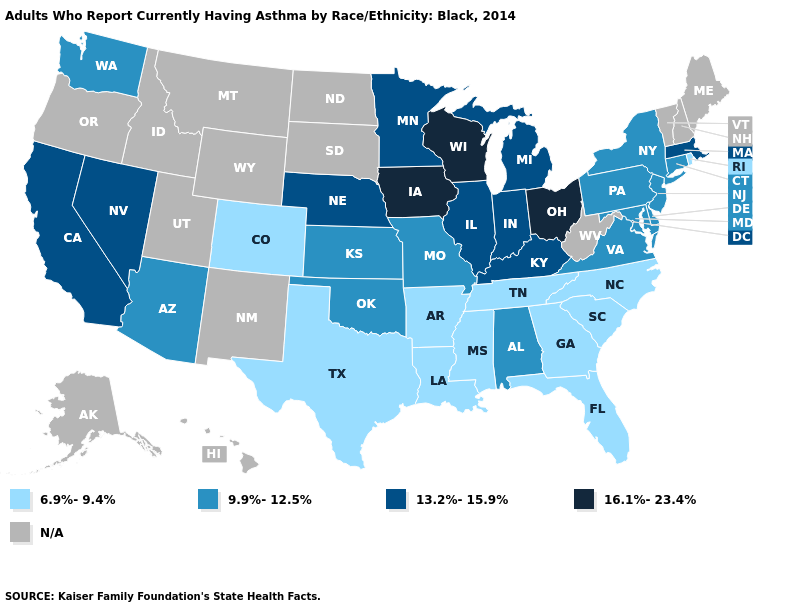Does the first symbol in the legend represent the smallest category?
Quick response, please. Yes. Name the states that have a value in the range 13.2%-15.9%?
Write a very short answer. California, Illinois, Indiana, Kentucky, Massachusetts, Michigan, Minnesota, Nebraska, Nevada. What is the value of Illinois?
Give a very brief answer. 13.2%-15.9%. How many symbols are there in the legend?
Concise answer only. 5. Name the states that have a value in the range N/A?
Short answer required. Alaska, Hawaii, Idaho, Maine, Montana, New Hampshire, New Mexico, North Dakota, Oregon, South Dakota, Utah, Vermont, West Virginia, Wyoming. What is the highest value in the USA?
Give a very brief answer. 16.1%-23.4%. What is the value of Missouri?
Concise answer only. 9.9%-12.5%. Name the states that have a value in the range 6.9%-9.4%?
Be succinct. Arkansas, Colorado, Florida, Georgia, Louisiana, Mississippi, North Carolina, Rhode Island, South Carolina, Tennessee, Texas. Does the first symbol in the legend represent the smallest category?
Write a very short answer. Yes. Which states hav the highest value in the West?
Concise answer only. California, Nevada. What is the value of Delaware?
Keep it brief. 9.9%-12.5%. Does the first symbol in the legend represent the smallest category?
Keep it brief. Yes. Which states have the highest value in the USA?
Quick response, please. Iowa, Ohio, Wisconsin. 